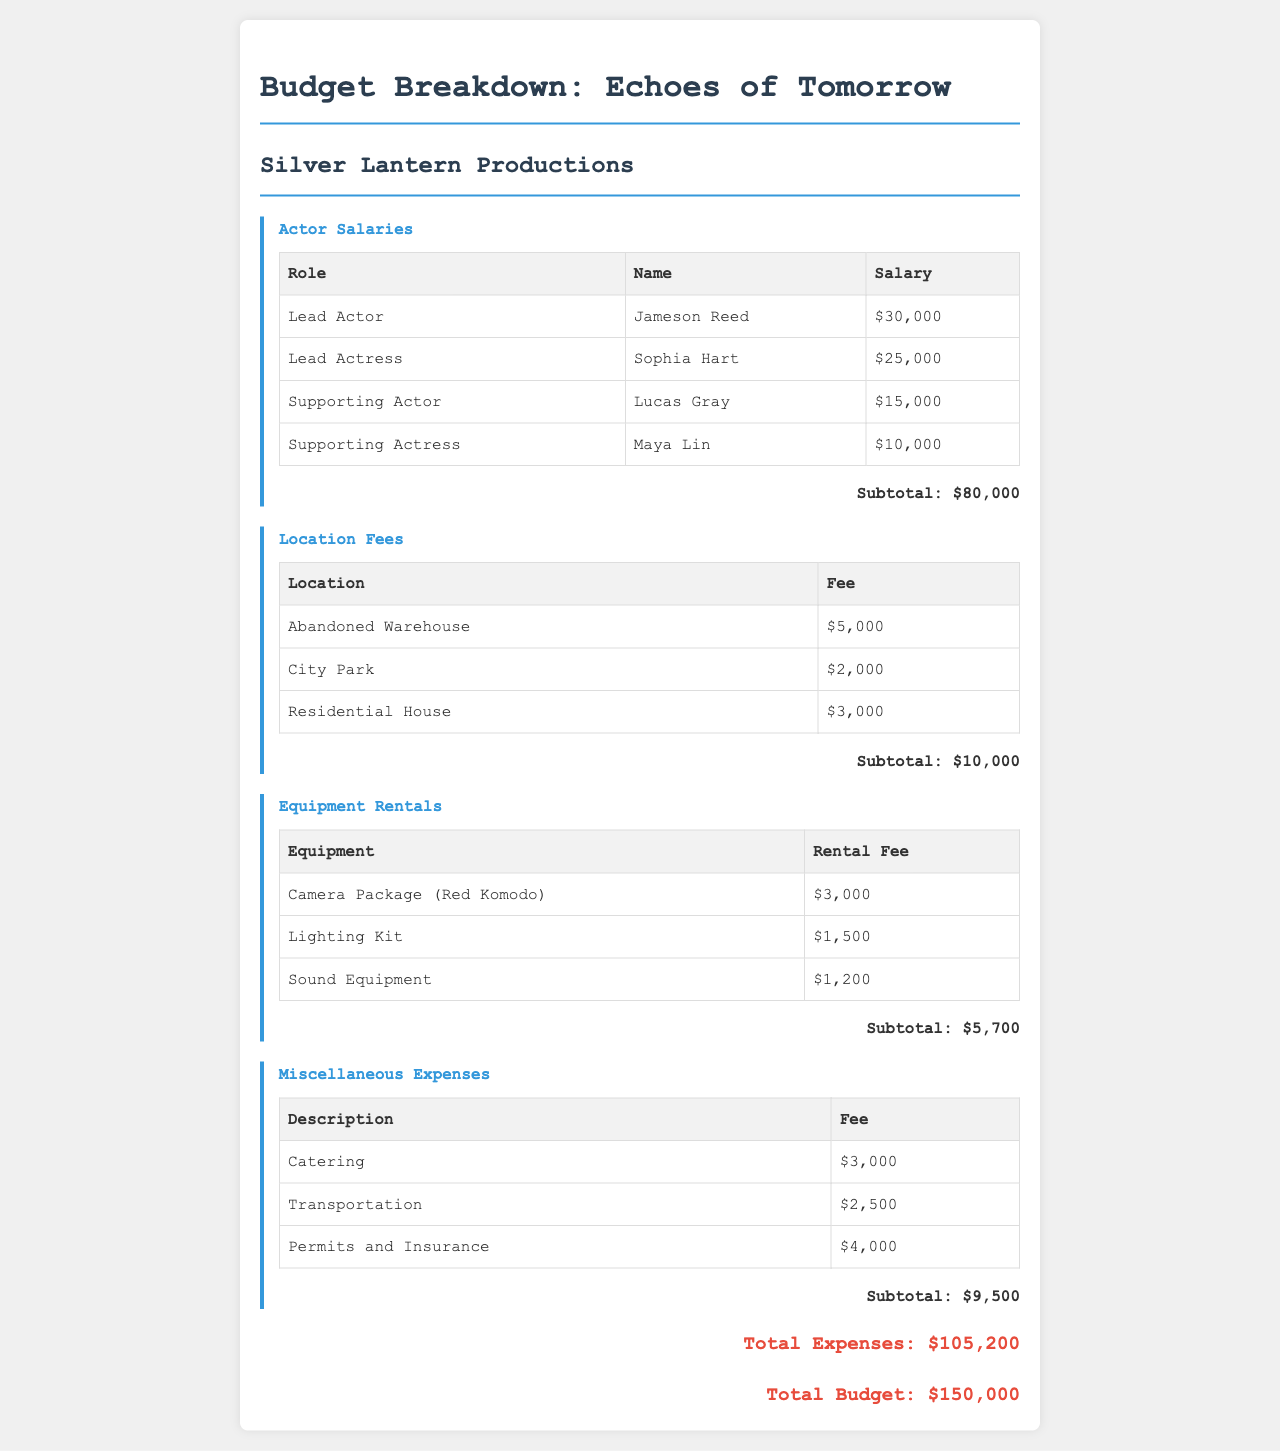What is the total budget? The total budget is specified at the bottom of the document, which is $150,000.
Answer: $150,000 Who is the lead actor? The lead actor's name is listed in the Actor Salaries section, which is Jameson Reed.
Answer: Jameson Reed What is the subtotal for location fees? The subtotal for location fees is provided at the end of that section, which totals $10,000.
Answer: $10,000 How much is the rental fee for the camera package? The rental fee for the camera package (Red Komodo) is detailed in the Equipment Rentals section, which is $3,000.
Answer: $3,000 What is the total expense? The total expense is shown at the bottom of the document as $105,200.
Answer: $105,200 How many supporting actors are listed? The document mentions two supporting actors, which can be found in the Actor Salaries section.
Answer: 2 What category does catering fall under? The document categorizes catering under Miscellaneous Expenses, as indicated in the respective section.
Answer: Miscellaneous Expenses What is the fee for permits and insurance? The fee for permits and insurance is provided in the Miscellaneous Expenses section, which is $4,000.
Answer: $4,000 Which actress's salary is lower: Lead Actress or Supporting Actress? By comparing their salaries in the Actor Salaries section, the Supporting Actress's salary is lower, which is $10,000 compared to $25,000.
Answer: Supporting Actress 